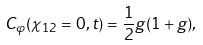Convert formula to latex. <formula><loc_0><loc_0><loc_500><loc_500>C _ { \varphi } ( \chi _ { 1 2 } = 0 , t ) = \frac { 1 } { 2 } g ( 1 + g ) ,</formula> 